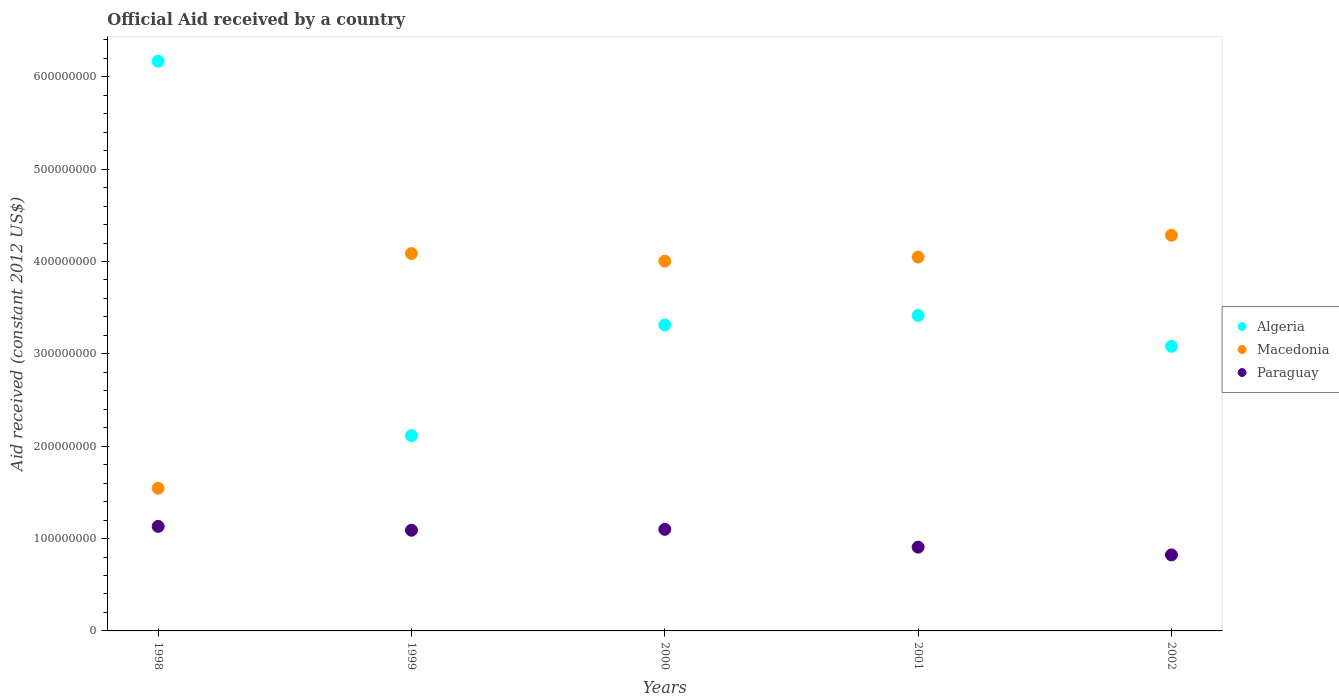What is the net official aid received in Macedonia in 2002?
Make the answer very short. 4.28e+08. Across all years, what is the maximum net official aid received in Macedonia?
Make the answer very short. 4.28e+08. Across all years, what is the minimum net official aid received in Macedonia?
Make the answer very short. 1.54e+08. In which year was the net official aid received in Algeria minimum?
Give a very brief answer. 1999. What is the total net official aid received in Algeria in the graph?
Your answer should be very brief. 1.81e+09. What is the difference between the net official aid received in Macedonia in 1998 and that in 2000?
Your answer should be compact. -2.46e+08. What is the difference between the net official aid received in Algeria in 1998 and the net official aid received in Macedonia in 2002?
Offer a terse response. 1.88e+08. What is the average net official aid received in Algeria per year?
Your answer should be very brief. 3.62e+08. In the year 2000, what is the difference between the net official aid received in Algeria and net official aid received in Paraguay?
Provide a short and direct response. 2.21e+08. What is the ratio of the net official aid received in Algeria in 2001 to that in 2002?
Your response must be concise. 1.11. What is the difference between the highest and the second highest net official aid received in Paraguay?
Ensure brevity in your answer.  3.18e+06. What is the difference between the highest and the lowest net official aid received in Paraguay?
Your response must be concise. 3.09e+07. Is the sum of the net official aid received in Paraguay in 2000 and 2001 greater than the maximum net official aid received in Algeria across all years?
Your answer should be very brief. No. Is it the case that in every year, the sum of the net official aid received in Paraguay and net official aid received in Macedonia  is greater than the net official aid received in Algeria?
Your response must be concise. No. Is the net official aid received in Paraguay strictly greater than the net official aid received in Macedonia over the years?
Provide a succinct answer. No. How many years are there in the graph?
Provide a succinct answer. 5. What is the difference between two consecutive major ticks on the Y-axis?
Offer a terse response. 1.00e+08. Are the values on the major ticks of Y-axis written in scientific E-notation?
Give a very brief answer. No. Does the graph contain grids?
Keep it short and to the point. No. What is the title of the graph?
Your answer should be compact. Official Aid received by a country. What is the label or title of the Y-axis?
Your response must be concise. Aid received (constant 2012 US$). What is the Aid received (constant 2012 US$) of Algeria in 1998?
Your answer should be very brief. 6.17e+08. What is the Aid received (constant 2012 US$) in Macedonia in 1998?
Offer a terse response. 1.54e+08. What is the Aid received (constant 2012 US$) of Paraguay in 1998?
Your response must be concise. 1.13e+08. What is the Aid received (constant 2012 US$) in Algeria in 1999?
Offer a very short reply. 2.11e+08. What is the Aid received (constant 2012 US$) in Macedonia in 1999?
Provide a succinct answer. 4.09e+08. What is the Aid received (constant 2012 US$) of Paraguay in 1999?
Your response must be concise. 1.09e+08. What is the Aid received (constant 2012 US$) of Algeria in 2000?
Ensure brevity in your answer.  3.31e+08. What is the Aid received (constant 2012 US$) of Macedonia in 2000?
Offer a very short reply. 4.00e+08. What is the Aid received (constant 2012 US$) of Paraguay in 2000?
Your answer should be very brief. 1.10e+08. What is the Aid received (constant 2012 US$) in Algeria in 2001?
Ensure brevity in your answer.  3.42e+08. What is the Aid received (constant 2012 US$) in Macedonia in 2001?
Provide a short and direct response. 4.05e+08. What is the Aid received (constant 2012 US$) in Paraguay in 2001?
Provide a succinct answer. 9.07e+07. What is the Aid received (constant 2012 US$) of Algeria in 2002?
Your response must be concise. 3.08e+08. What is the Aid received (constant 2012 US$) in Macedonia in 2002?
Offer a very short reply. 4.28e+08. What is the Aid received (constant 2012 US$) of Paraguay in 2002?
Your answer should be very brief. 8.23e+07. Across all years, what is the maximum Aid received (constant 2012 US$) in Algeria?
Keep it short and to the point. 6.17e+08. Across all years, what is the maximum Aid received (constant 2012 US$) in Macedonia?
Your answer should be very brief. 4.28e+08. Across all years, what is the maximum Aid received (constant 2012 US$) of Paraguay?
Make the answer very short. 1.13e+08. Across all years, what is the minimum Aid received (constant 2012 US$) in Algeria?
Provide a succinct answer. 2.11e+08. Across all years, what is the minimum Aid received (constant 2012 US$) of Macedonia?
Your response must be concise. 1.54e+08. Across all years, what is the minimum Aid received (constant 2012 US$) of Paraguay?
Provide a succinct answer. 8.23e+07. What is the total Aid received (constant 2012 US$) of Algeria in the graph?
Keep it short and to the point. 1.81e+09. What is the total Aid received (constant 2012 US$) of Macedonia in the graph?
Offer a terse response. 1.80e+09. What is the total Aid received (constant 2012 US$) of Paraguay in the graph?
Your answer should be compact. 5.05e+08. What is the difference between the Aid received (constant 2012 US$) in Algeria in 1998 and that in 1999?
Make the answer very short. 4.05e+08. What is the difference between the Aid received (constant 2012 US$) of Macedonia in 1998 and that in 1999?
Keep it short and to the point. -2.54e+08. What is the difference between the Aid received (constant 2012 US$) in Paraguay in 1998 and that in 1999?
Offer a terse response. 4.15e+06. What is the difference between the Aid received (constant 2012 US$) of Algeria in 1998 and that in 2000?
Provide a succinct answer. 2.86e+08. What is the difference between the Aid received (constant 2012 US$) of Macedonia in 1998 and that in 2000?
Keep it short and to the point. -2.46e+08. What is the difference between the Aid received (constant 2012 US$) in Paraguay in 1998 and that in 2000?
Your response must be concise. 3.18e+06. What is the difference between the Aid received (constant 2012 US$) in Algeria in 1998 and that in 2001?
Your response must be concise. 2.75e+08. What is the difference between the Aid received (constant 2012 US$) in Macedonia in 1998 and that in 2001?
Your response must be concise. -2.50e+08. What is the difference between the Aid received (constant 2012 US$) of Paraguay in 1998 and that in 2001?
Your answer should be very brief. 2.25e+07. What is the difference between the Aid received (constant 2012 US$) of Algeria in 1998 and that in 2002?
Provide a succinct answer. 3.09e+08. What is the difference between the Aid received (constant 2012 US$) in Macedonia in 1998 and that in 2002?
Your response must be concise. -2.74e+08. What is the difference between the Aid received (constant 2012 US$) in Paraguay in 1998 and that in 2002?
Keep it short and to the point. 3.09e+07. What is the difference between the Aid received (constant 2012 US$) in Algeria in 1999 and that in 2000?
Provide a short and direct response. -1.20e+08. What is the difference between the Aid received (constant 2012 US$) in Macedonia in 1999 and that in 2000?
Offer a terse response. 8.27e+06. What is the difference between the Aid received (constant 2012 US$) of Paraguay in 1999 and that in 2000?
Your answer should be very brief. -9.70e+05. What is the difference between the Aid received (constant 2012 US$) in Algeria in 1999 and that in 2001?
Keep it short and to the point. -1.30e+08. What is the difference between the Aid received (constant 2012 US$) of Macedonia in 1999 and that in 2001?
Offer a very short reply. 3.84e+06. What is the difference between the Aid received (constant 2012 US$) in Paraguay in 1999 and that in 2001?
Provide a short and direct response. 1.83e+07. What is the difference between the Aid received (constant 2012 US$) of Algeria in 1999 and that in 2002?
Provide a short and direct response. -9.67e+07. What is the difference between the Aid received (constant 2012 US$) of Macedonia in 1999 and that in 2002?
Your answer should be very brief. -1.98e+07. What is the difference between the Aid received (constant 2012 US$) in Paraguay in 1999 and that in 2002?
Provide a succinct answer. 2.67e+07. What is the difference between the Aid received (constant 2012 US$) in Algeria in 2000 and that in 2001?
Keep it short and to the point. -1.03e+07. What is the difference between the Aid received (constant 2012 US$) in Macedonia in 2000 and that in 2001?
Offer a very short reply. -4.43e+06. What is the difference between the Aid received (constant 2012 US$) in Paraguay in 2000 and that in 2001?
Keep it short and to the point. 1.93e+07. What is the difference between the Aid received (constant 2012 US$) in Algeria in 2000 and that in 2002?
Offer a very short reply. 2.31e+07. What is the difference between the Aid received (constant 2012 US$) of Macedonia in 2000 and that in 2002?
Provide a succinct answer. -2.81e+07. What is the difference between the Aid received (constant 2012 US$) of Paraguay in 2000 and that in 2002?
Offer a terse response. 2.77e+07. What is the difference between the Aid received (constant 2012 US$) in Algeria in 2001 and that in 2002?
Provide a succinct answer. 3.34e+07. What is the difference between the Aid received (constant 2012 US$) in Macedonia in 2001 and that in 2002?
Offer a very short reply. -2.36e+07. What is the difference between the Aid received (constant 2012 US$) in Paraguay in 2001 and that in 2002?
Provide a short and direct response. 8.41e+06. What is the difference between the Aid received (constant 2012 US$) of Algeria in 1998 and the Aid received (constant 2012 US$) of Macedonia in 1999?
Your answer should be very brief. 2.08e+08. What is the difference between the Aid received (constant 2012 US$) of Algeria in 1998 and the Aid received (constant 2012 US$) of Paraguay in 1999?
Offer a very short reply. 5.08e+08. What is the difference between the Aid received (constant 2012 US$) of Macedonia in 1998 and the Aid received (constant 2012 US$) of Paraguay in 1999?
Offer a very short reply. 4.54e+07. What is the difference between the Aid received (constant 2012 US$) of Algeria in 1998 and the Aid received (constant 2012 US$) of Macedonia in 2000?
Provide a succinct answer. 2.16e+08. What is the difference between the Aid received (constant 2012 US$) in Algeria in 1998 and the Aid received (constant 2012 US$) in Paraguay in 2000?
Give a very brief answer. 5.07e+08. What is the difference between the Aid received (constant 2012 US$) of Macedonia in 1998 and the Aid received (constant 2012 US$) of Paraguay in 2000?
Your answer should be very brief. 4.45e+07. What is the difference between the Aid received (constant 2012 US$) of Algeria in 1998 and the Aid received (constant 2012 US$) of Macedonia in 2001?
Ensure brevity in your answer.  2.12e+08. What is the difference between the Aid received (constant 2012 US$) in Algeria in 1998 and the Aid received (constant 2012 US$) in Paraguay in 2001?
Your answer should be compact. 5.26e+08. What is the difference between the Aid received (constant 2012 US$) in Macedonia in 1998 and the Aid received (constant 2012 US$) in Paraguay in 2001?
Make the answer very short. 6.38e+07. What is the difference between the Aid received (constant 2012 US$) of Algeria in 1998 and the Aid received (constant 2012 US$) of Macedonia in 2002?
Make the answer very short. 1.88e+08. What is the difference between the Aid received (constant 2012 US$) in Algeria in 1998 and the Aid received (constant 2012 US$) in Paraguay in 2002?
Make the answer very short. 5.35e+08. What is the difference between the Aid received (constant 2012 US$) of Macedonia in 1998 and the Aid received (constant 2012 US$) of Paraguay in 2002?
Provide a succinct answer. 7.22e+07. What is the difference between the Aid received (constant 2012 US$) of Algeria in 1999 and the Aid received (constant 2012 US$) of Macedonia in 2000?
Make the answer very short. -1.89e+08. What is the difference between the Aid received (constant 2012 US$) of Algeria in 1999 and the Aid received (constant 2012 US$) of Paraguay in 2000?
Make the answer very short. 1.01e+08. What is the difference between the Aid received (constant 2012 US$) of Macedonia in 1999 and the Aid received (constant 2012 US$) of Paraguay in 2000?
Your answer should be compact. 2.99e+08. What is the difference between the Aid received (constant 2012 US$) of Algeria in 1999 and the Aid received (constant 2012 US$) of Macedonia in 2001?
Your response must be concise. -1.93e+08. What is the difference between the Aid received (constant 2012 US$) in Algeria in 1999 and the Aid received (constant 2012 US$) in Paraguay in 2001?
Offer a very short reply. 1.21e+08. What is the difference between the Aid received (constant 2012 US$) of Macedonia in 1999 and the Aid received (constant 2012 US$) of Paraguay in 2001?
Offer a terse response. 3.18e+08. What is the difference between the Aid received (constant 2012 US$) in Algeria in 1999 and the Aid received (constant 2012 US$) in Macedonia in 2002?
Give a very brief answer. -2.17e+08. What is the difference between the Aid received (constant 2012 US$) in Algeria in 1999 and the Aid received (constant 2012 US$) in Paraguay in 2002?
Provide a succinct answer. 1.29e+08. What is the difference between the Aid received (constant 2012 US$) of Macedonia in 1999 and the Aid received (constant 2012 US$) of Paraguay in 2002?
Provide a short and direct response. 3.26e+08. What is the difference between the Aid received (constant 2012 US$) of Algeria in 2000 and the Aid received (constant 2012 US$) of Macedonia in 2001?
Your answer should be compact. -7.36e+07. What is the difference between the Aid received (constant 2012 US$) of Algeria in 2000 and the Aid received (constant 2012 US$) of Paraguay in 2001?
Offer a very short reply. 2.41e+08. What is the difference between the Aid received (constant 2012 US$) of Macedonia in 2000 and the Aid received (constant 2012 US$) of Paraguay in 2001?
Provide a short and direct response. 3.10e+08. What is the difference between the Aid received (constant 2012 US$) in Algeria in 2000 and the Aid received (constant 2012 US$) in Macedonia in 2002?
Make the answer very short. -9.72e+07. What is the difference between the Aid received (constant 2012 US$) of Algeria in 2000 and the Aid received (constant 2012 US$) of Paraguay in 2002?
Keep it short and to the point. 2.49e+08. What is the difference between the Aid received (constant 2012 US$) of Macedonia in 2000 and the Aid received (constant 2012 US$) of Paraguay in 2002?
Offer a very short reply. 3.18e+08. What is the difference between the Aid received (constant 2012 US$) in Algeria in 2001 and the Aid received (constant 2012 US$) in Macedonia in 2002?
Your answer should be very brief. -8.69e+07. What is the difference between the Aid received (constant 2012 US$) of Algeria in 2001 and the Aid received (constant 2012 US$) of Paraguay in 2002?
Your answer should be very brief. 2.59e+08. What is the difference between the Aid received (constant 2012 US$) of Macedonia in 2001 and the Aid received (constant 2012 US$) of Paraguay in 2002?
Provide a short and direct response. 3.23e+08. What is the average Aid received (constant 2012 US$) of Algeria per year?
Provide a succinct answer. 3.62e+08. What is the average Aid received (constant 2012 US$) in Macedonia per year?
Offer a terse response. 3.59e+08. What is the average Aid received (constant 2012 US$) of Paraguay per year?
Your answer should be compact. 1.01e+08. In the year 1998, what is the difference between the Aid received (constant 2012 US$) of Algeria and Aid received (constant 2012 US$) of Macedonia?
Your response must be concise. 4.62e+08. In the year 1998, what is the difference between the Aid received (constant 2012 US$) of Algeria and Aid received (constant 2012 US$) of Paraguay?
Provide a short and direct response. 5.04e+08. In the year 1998, what is the difference between the Aid received (constant 2012 US$) of Macedonia and Aid received (constant 2012 US$) of Paraguay?
Ensure brevity in your answer.  4.13e+07. In the year 1999, what is the difference between the Aid received (constant 2012 US$) in Algeria and Aid received (constant 2012 US$) in Macedonia?
Ensure brevity in your answer.  -1.97e+08. In the year 1999, what is the difference between the Aid received (constant 2012 US$) in Algeria and Aid received (constant 2012 US$) in Paraguay?
Keep it short and to the point. 1.02e+08. In the year 1999, what is the difference between the Aid received (constant 2012 US$) in Macedonia and Aid received (constant 2012 US$) in Paraguay?
Ensure brevity in your answer.  3.00e+08. In the year 2000, what is the difference between the Aid received (constant 2012 US$) of Algeria and Aid received (constant 2012 US$) of Macedonia?
Make the answer very short. -6.91e+07. In the year 2000, what is the difference between the Aid received (constant 2012 US$) of Algeria and Aid received (constant 2012 US$) of Paraguay?
Keep it short and to the point. 2.21e+08. In the year 2000, what is the difference between the Aid received (constant 2012 US$) in Macedonia and Aid received (constant 2012 US$) in Paraguay?
Provide a succinct answer. 2.90e+08. In the year 2001, what is the difference between the Aid received (constant 2012 US$) of Algeria and Aid received (constant 2012 US$) of Macedonia?
Make the answer very short. -6.32e+07. In the year 2001, what is the difference between the Aid received (constant 2012 US$) of Algeria and Aid received (constant 2012 US$) of Paraguay?
Make the answer very short. 2.51e+08. In the year 2001, what is the difference between the Aid received (constant 2012 US$) in Macedonia and Aid received (constant 2012 US$) in Paraguay?
Provide a succinct answer. 3.14e+08. In the year 2002, what is the difference between the Aid received (constant 2012 US$) of Algeria and Aid received (constant 2012 US$) of Macedonia?
Offer a very short reply. -1.20e+08. In the year 2002, what is the difference between the Aid received (constant 2012 US$) of Algeria and Aid received (constant 2012 US$) of Paraguay?
Offer a terse response. 2.26e+08. In the year 2002, what is the difference between the Aid received (constant 2012 US$) of Macedonia and Aid received (constant 2012 US$) of Paraguay?
Your response must be concise. 3.46e+08. What is the ratio of the Aid received (constant 2012 US$) of Algeria in 1998 to that in 1999?
Your answer should be very brief. 2.92. What is the ratio of the Aid received (constant 2012 US$) of Macedonia in 1998 to that in 1999?
Make the answer very short. 0.38. What is the ratio of the Aid received (constant 2012 US$) of Paraguay in 1998 to that in 1999?
Keep it short and to the point. 1.04. What is the ratio of the Aid received (constant 2012 US$) in Algeria in 1998 to that in 2000?
Your answer should be compact. 1.86. What is the ratio of the Aid received (constant 2012 US$) of Macedonia in 1998 to that in 2000?
Offer a terse response. 0.39. What is the ratio of the Aid received (constant 2012 US$) of Paraguay in 1998 to that in 2000?
Your response must be concise. 1.03. What is the ratio of the Aid received (constant 2012 US$) in Algeria in 1998 to that in 2001?
Give a very brief answer. 1.81. What is the ratio of the Aid received (constant 2012 US$) of Macedonia in 1998 to that in 2001?
Make the answer very short. 0.38. What is the ratio of the Aid received (constant 2012 US$) in Paraguay in 1998 to that in 2001?
Your answer should be very brief. 1.25. What is the ratio of the Aid received (constant 2012 US$) of Algeria in 1998 to that in 2002?
Provide a short and direct response. 2. What is the ratio of the Aid received (constant 2012 US$) in Macedonia in 1998 to that in 2002?
Provide a succinct answer. 0.36. What is the ratio of the Aid received (constant 2012 US$) of Paraguay in 1998 to that in 2002?
Your answer should be very brief. 1.38. What is the ratio of the Aid received (constant 2012 US$) in Algeria in 1999 to that in 2000?
Ensure brevity in your answer.  0.64. What is the ratio of the Aid received (constant 2012 US$) in Macedonia in 1999 to that in 2000?
Offer a very short reply. 1.02. What is the ratio of the Aid received (constant 2012 US$) of Algeria in 1999 to that in 2001?
Your answer should be compact. 0.62. What is the ratio of the Aid received (constant 2012 US$) in Macedonia in 1999 to that in 2001?
Provide a succinct answer. 1.01. What is the ratio of the Aid received (constant 2012 US$) in Paraguay in 1999 to that in 2001?
Make the answer very short. 1.2. What is the ratio of the Aid received (constant 2012 US$) of Algeria in 1999 to that in 2002?
Offer a terse response. 0.69. What is the ratio of the Aid received (constant 2012 US$) in Macedonia in 1999 to that in 2002?
Give a very brief answer. 0.95. What is the ratio of the Aid received (constant 2012 US$) in Paraguay in 1999 to that in 2002?
Give a very brief answer. 1.32. What is the ratio of the Aid received (constant 2012 US$) in Algeria in 2000 to that in 2001?
Your answer should be compact. 0.97. What is the ratio of the Aid received (constant 2012 US$) of Paraguay in 2000 to that in 2001?
Offer a very short reply. 1.21. What is the ratio of the Aid received (constant 2012 US$) in Algeria in 2000 to that in 2002?
Ensure brevity in your answer.  1.07. What is the ratio of the Aid received (constant 2012 US$) of Macedonia in 2000 to that in 2002?
Give a very brief answer. 0.93. What is the ratio of the Aid received (constant 2012 US$) in Paraguay in 2000 to that in 2002?
Offer a very short reply. 1.34. What is the ratio of the Aid received (constant 2012 US$) of Algeria in 2001 to that in 2002?
Your answer should be compact. 1.11. What is the ratio of the Aid received (constant 2012 US$) in Macedonia in 2001 to that in 2002?
Your answer should be compact. 0.94. What is the ratio of the Aid received (constant 2012 US$) in Paraguay in 2001 to that in 2002?
Make the answer very short. 1.1. What is the difference between the highest and the second highest Aid received (constant 2012 US$) in Algeria?
Your answer should be compact. 2.75e+08. What is the difference between the highest and the second highest Aid received (constant 2012 US$) of Macedonia?
Offer a terse response. 1.98e+07. What is the difference between the highest and the second highest Aid received (constant 2012 US$) of Paraguay?
Make the answer very short. 3.18e+06. What is the difference between the highest and the lowest Aid received (constant 2012 US$) of Algeria?
Offer a terse response. 4.05e+08. What is the difference between the highest and the lowest Aid received (constant 2012 US$) of Macedonia?
Your answer should be compact. 2.74e+08. What is the difference between the highest and the lowest Aid received (constant 2012 US$) of Paraguay?
Offer a very short reply. 3.09e+07. 